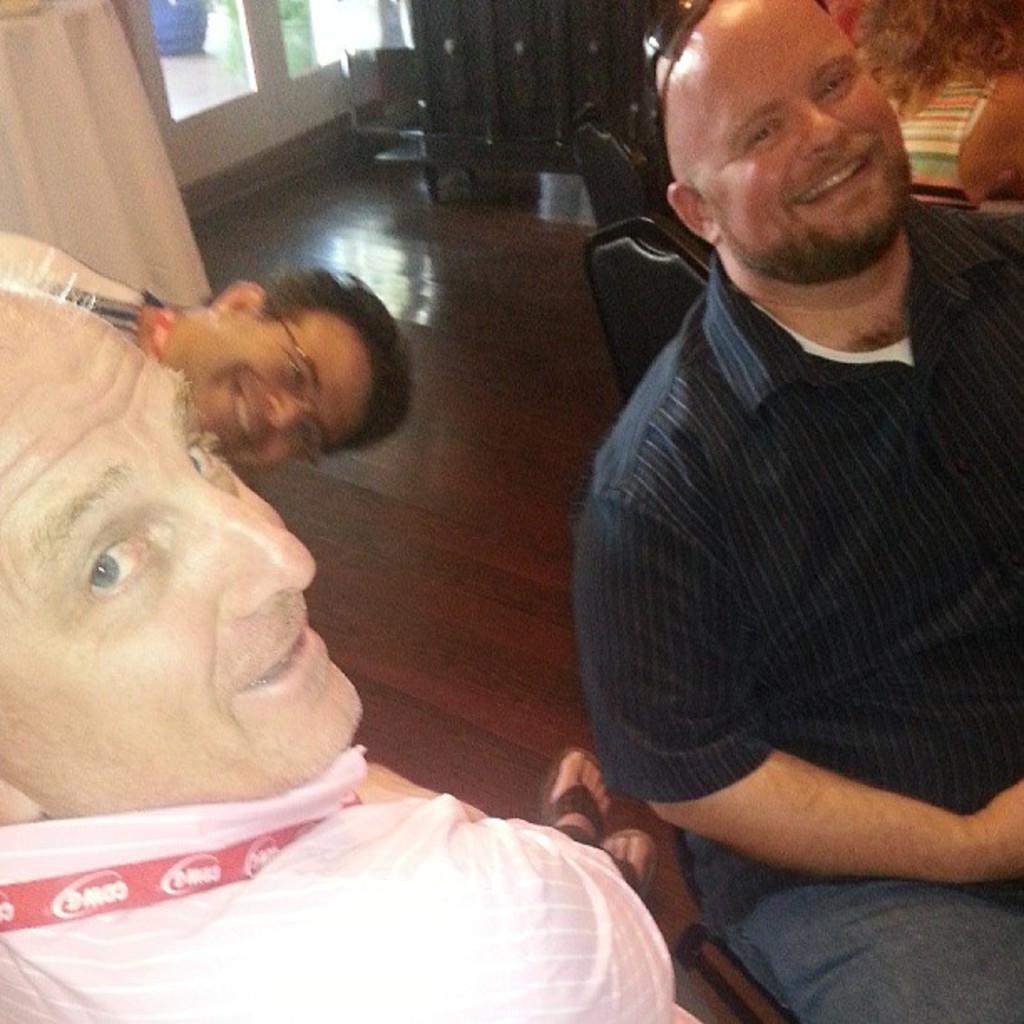Describe this image in one or two sentences. Nice image we can see these persons are sitting and smiling here we can see wooden flooring shares wooden cupboards and the class one dose in the background 